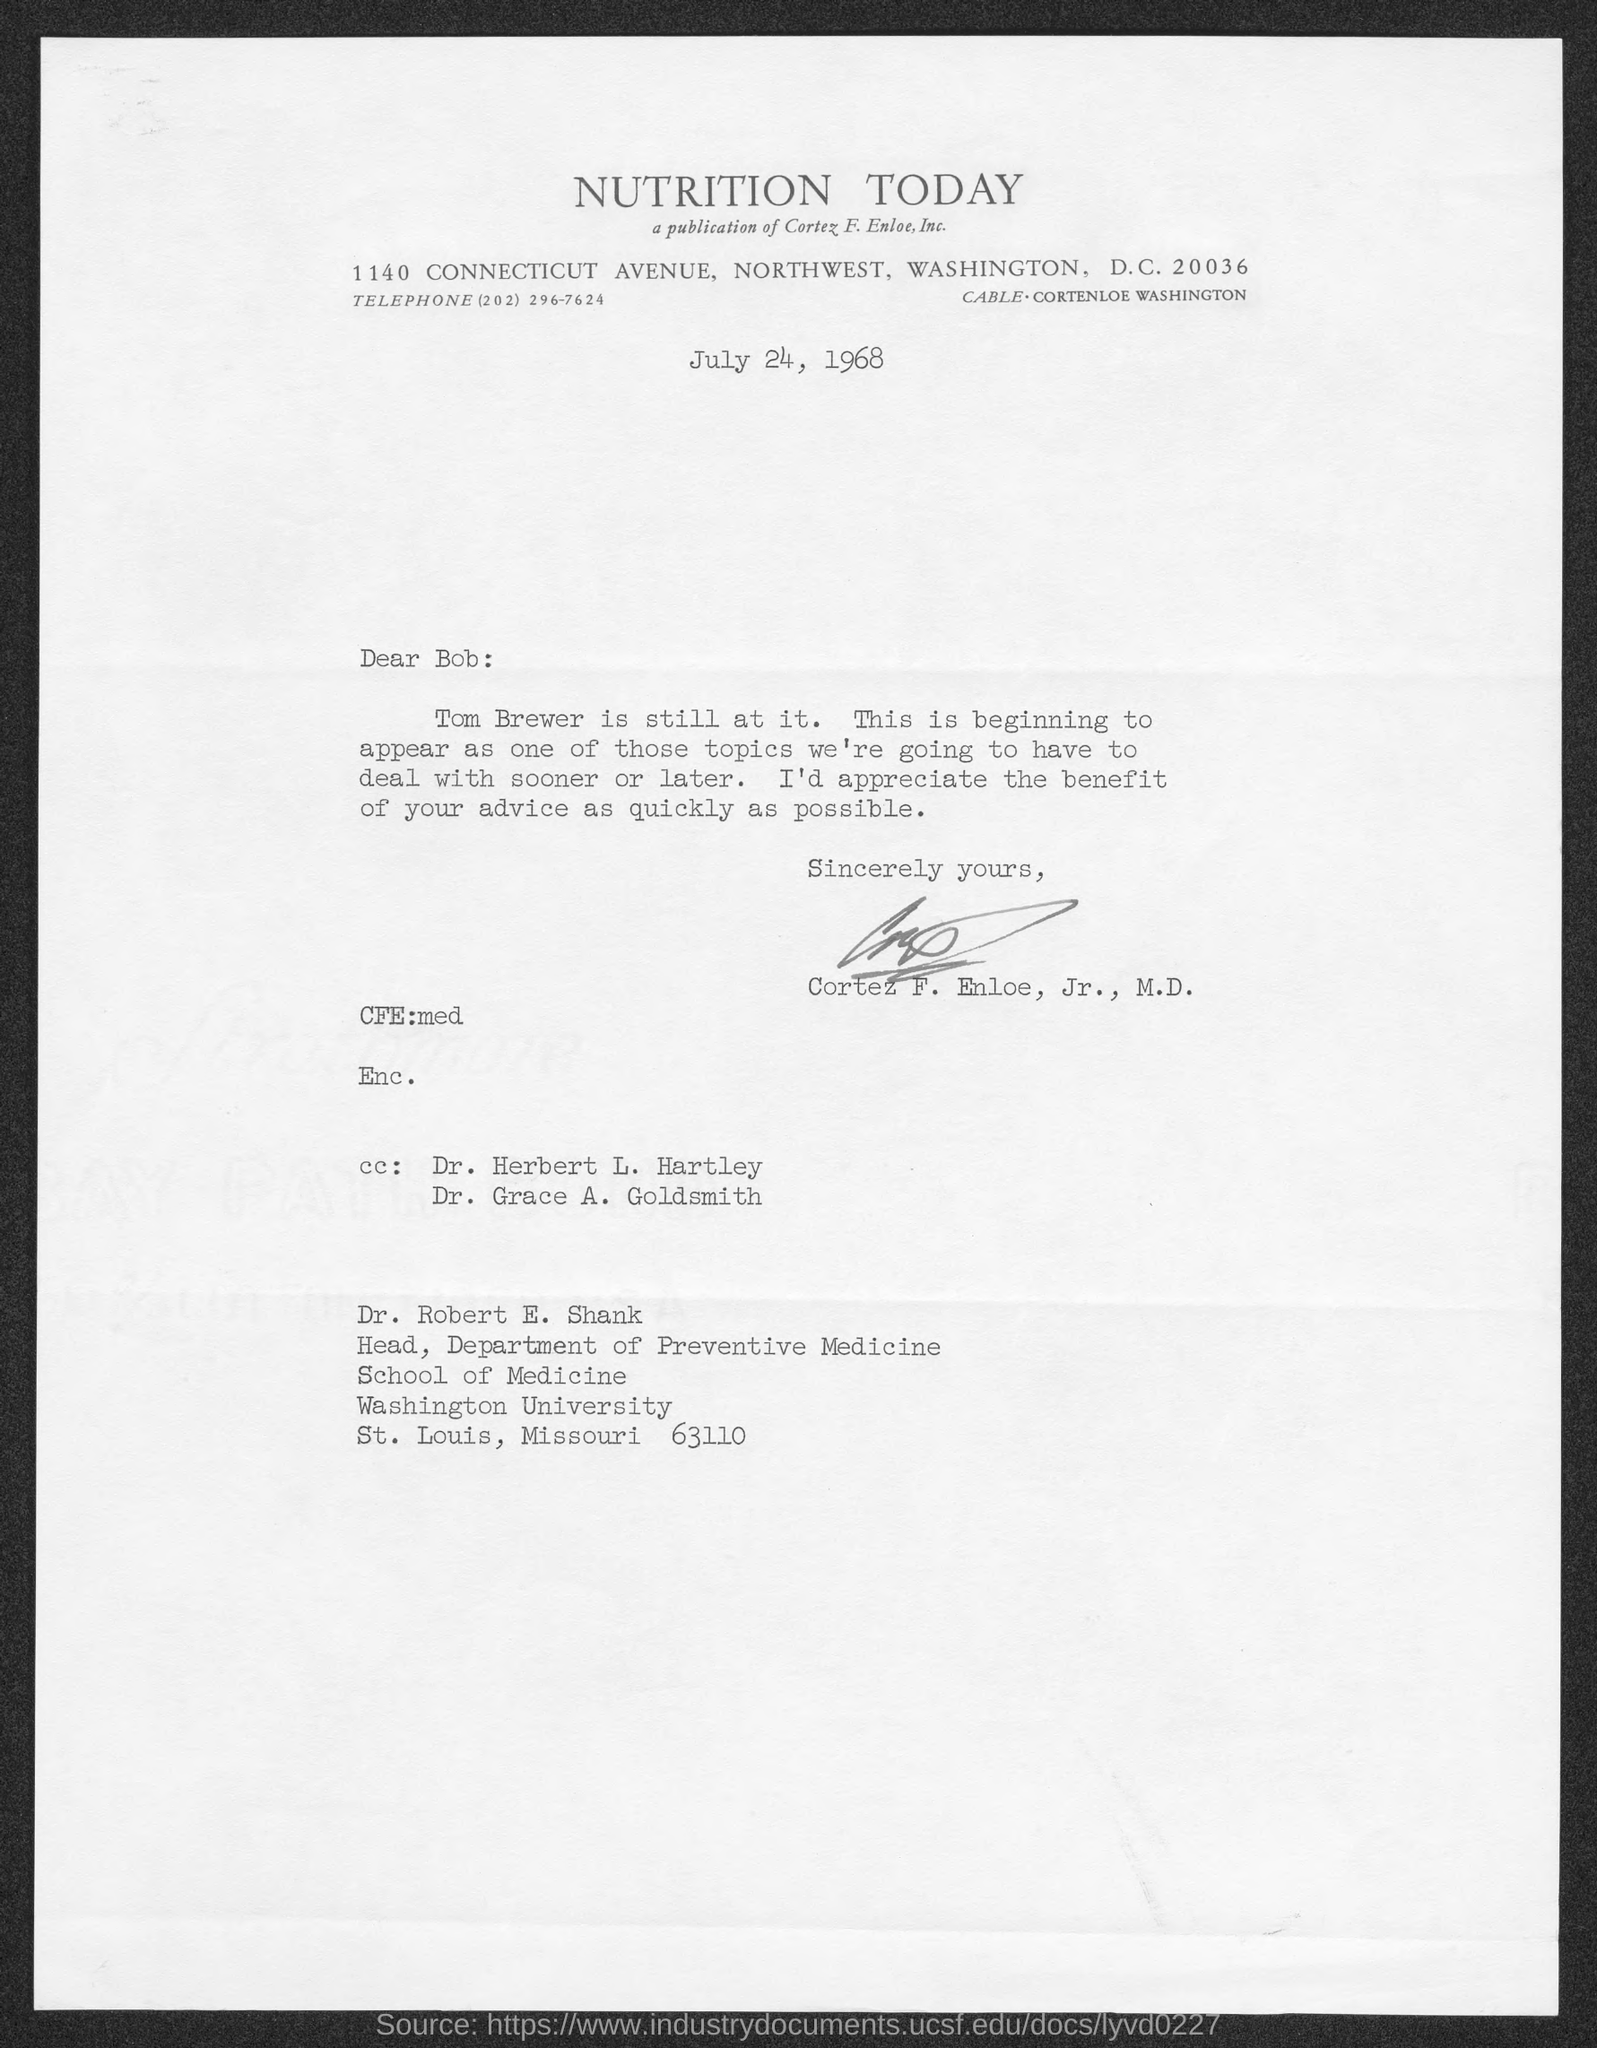Outline some significant characteristics in this image. The date on which this letter is sent is JULY 24, 1968. The letter is addressed to Dr. Robert E. Shank. The Head of the Department of Preventive Medicine is Dr. Robert E. Shank. The letterhead mentions a journal called 'NUTRITION TODAY.' 